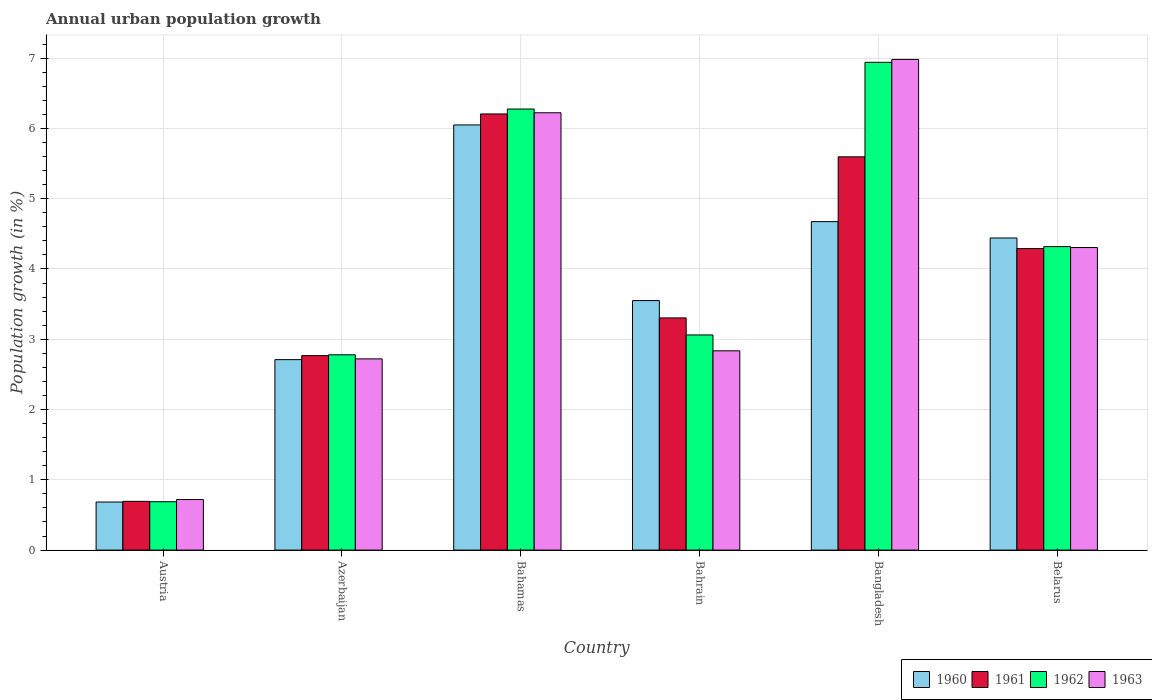How many groups of bars are there?
Your response must be concise. 6. Are the number of bars per tick equal to the number of legend labels?
Your response must be concise. Yes. Are the number of bars on each tick of the X-axis equal?
Your response must be concise. Yes. What is the percentage of urban population growth in 1962 in Austria?
Offer a very short reply. 0.69. Across all countries, what is the maximum percentage of urban population growth in 1961?
Keep it short and to the point. 6.21. Across all countries, what is the minimum percentage of urban population growth in 1962?
Ensure brevity in your answer.  0.69. In which country was the percentage of urban population growth in 1961 maximum?
Provide a succinct answer. Bahamas. In which country was the percentage of urban population growth in 1961 minimum?
Your answer should be very brief. Austria. What is the total percentage of urban population growth in 1961 in the graph?
Your response must be concise. 22.86. What is the difference between the percentage of urban population growth in 1963 in Azerbaijan and that in Bahrain?
Your answer should be compact. -0.11. What is the difference between the percentage of urban population growth in 1962 in Belarus and the percentage of urban population growth in 1960 in Bangladesh?
Give a very brief answer. -0.36. What is the average percentage of urban population growth in 1963 per country?
Your answer should be very brief. 3.96. What is the difference between the percentage of urban population growth of/in 1962 and percentage of urban population growth of/in 1961 in Bahamas?
Offer a very short reply. 0.07. In how many countries, is the percentage of urban population growth in 1960 greater than 4.6 %?
Offer a very short reply. 2. What is the ratio of the percentage of urban population growth in 1962 in Austria to that in Bahrain?
Your answer should be compact. 0.22. Is the difference between the percentage of urban population growth in 1962 in Austria and Bahrain greater than the difference between the percentage of urban population growth in 1961 in Austria and Bahrain?
Keep it short and to the point. Yes. What is the difference between the highest and the second highest percentage of urban population growth in 1961?
Offer a terse response. -1.31. What is the difference between the highest and the lowest percentage of urban population growth in 1960?
Offer a terse response. 5.37. In how many countries, is the percentage of urban population growth in 1961 greater than the average percentage of urban population growth in 1961 taken over all countries?
Offer a terse response. 3. What does the 1st bar from the left in Azerbaijan represents?
Give a very brief answer. 1960. What does the 4th bar from the right in Austria represents?
Ensure brevity in your answer.  1960. What is the difference between two consecutive major ticks on the Y-axis?
Keep it short and to the point. 1. Are the values on the major ticks of Y-axis written in scientific E-notation?
Your response must be concise. No. Does the graph contain any zero values?
Give a very brief answer. No. Does the graph contain grids?
Ensure brevity in your answer.  Yes. Where does the legend appear in the graph?
Make the answer very short. Bottom right. What is the title of the graph?
Give a very brief answer. Annual urban population growth. What is the label or title of the X-axis?
Offer a terse response. Country. What is the label or title of the Y-axis?
Your answer should be very brief. Population growth (in %). What is the Population growth (in %) of 1960 in Austria?
Your answer should be compact. 0.68. What is the Population growth (in %) of 1961 in Austria?
Ensure brevity in your answer.  0.69. What is the Population growth (in %) of 1962 in Austria?
Your response must be concise. 0.69. What is the Population growth (in %) of 1963 in Austria?
Ensure brevity in your answer.  0.72. What is the Population growth (in %) of 1960 in Azerbaijan?
Give a very brief answer. 2.71. What is the Population growth (in %) of 1961 in Azerbaijan?
Provide a succinct answer. 2.77. What is the Population growth (in %) in 1962 in Azerbaijan?
Offer a terse response. 2.78. What is the Population growth (in %) of 1963 in Azerbaijan?
Ensure brevity in your answer.  2.72. What is the Population growth (in %) in 1960 in Bahamas?
Your response must be concise. 6.05. What is the Population growth (in %) in 1961 in Bahamas?
Your response must be concise. 6.21. What is the Population growth (in %) in 1962 in Bahamas?
Your answer should be compact. 6.28. What is the Population growth (in %) in 1963 in Bahamas?
Give a very brief answer. 6.22. What is the Population growth (in %) of 1960 in Bahrain?
Keep it short and to the point. 3.55. What is the Population growth (in %) in 1961 in Bahrain?
Ensure brevity in your answer.  3.3. What is the Population growth (in %) of 1962 in Bahrain?
Your answer should be compact. 3.06. What is the Population growth (in %) in 1963 in Bahrain?
Provide a short and direct response. 2.84. What is the Population growth (in %) of 1960 in Bangladesh?
Ensure brevity in your answer.  4.67. What is the Population growth (in %) in 1961 in Bangladesh?
Give a very brief answer. 5.6. What is the Population growth (in %) of 1962 in Bangladesh?
Offer a very short reply. 6.94. What is the Population growth (in %) of 1963 in Bangladesh?
Give a very brief answer. 6.98. What is the Population growth (in %) of 1960 in Belarus?
Your response must be concise. 4.44. What is the Population growth (in %) of 1961 in Belarus?
Provide a succinct answer. 4.29. What is the Population growth (in %) of 1962 in Belarus?
Your response must be concise. 4.32. What is the Population growth (in %) of 1963 in Belarus?
Give a very brief answer. 4.31. Across all countries, what is the maximum Population growth (in %) of 1960?
Offer a terse response. 6.05. Across all countries, what is the maximum Population growth (in %) of 1961?
Your answer should be very brief. 6.21. Across all countries, what is the maximum Population growth (in %) in 1962?
Offer a very short reply. 6.94. Across all countries, what is the maximum Population growth (in %) of 1963?
Offer a terse response. 6.98. Across all countries, what is the minimum Population growth (in %) of 1960?
Make the answer very short. 0.68. Across all countries, what is the minimum Population growth (in %) in 1961?
Your answer should be very brief. 0.69. Across all countries, what is the minimum Population growth (in %) in 1962?
Keep it short and to the point. 0.69. Across all countries, what is the minimum Population growth (in %) of 1963?
Make the answer very short. 0.72. What is the total Population growth (in %) of 1960 in the graph?
Offer a terse response. 22.11. What is the total Population growth (in %) in 1961 in the graph?
Your response must be concise. 22.86. What is the total Population growth (in %) in 1962 in the graph?
Keep it short and to the point. 24.06. What is the total Population growth (in %) in 1963 in the graph?
Provide a short and direct response. 23.78. What is the difference between the Population growth (in %) of 1960 in Austria and that in Azerbaijan?
Keep it short and to the point. -2.03. What is the difference between the Population growth (in %) of 1961 in Austria and that in Azerbaijan?
Offer a very short reply. -2.07. What is the difference between the Population growth (in %) of 1962 in Austria and that in Azerbaijan?
Your answer should be very brief. -2.09. What is the difference between the Population growth (in %) in 1963 in Austria and that in Azerbaijan?
Your answer should be compact. -2. What is the difference between the Population growth (in %) of 1960 in Austria and that in Bahamas?
Your answer should be very brief. -5.37. What is the difference between the Population growth (in %) in 1961 in Austria and that in Bahamas?
Your response must be concise. -5.51. What is the difference between the Population growth (in %) of 1962 in Austria and that in Bahamas?
Offer a terse response. -5.59. What is the difference between the Population growth (in %) in 1963 in Austria and that in Bahamas?
Give a very brief answer. -5.5. What is the difference between the Population growth (in %) of 1960 in Austria and that in Bahrain?
Your answer should be very brief. -2.87. What is the difference between the Population growth (in %) of 1961 in Austria and that in Bahrain?
Your answer should be very brief. -2.61. What is the difference between the Population growth (in %) of 1962 in Austria and that in Bahrain?
Give a very brief answer. -2.37. What is the difference between the Population growth (in %) in 1963 in Austria and that in Bahrain?
Your response must be concise. -2.12. What is the difference between the Population growth (in %) in 1960 in Austria and that in Bangladesh?
Keep it short and to the point. -3.99. What is the difference between the Population growth (in %) in 1961 in Austria and that in Bangladesh?
Make the answer very short. -4.9. What is the difference between the Population growth (in %) in 1962 in Austria and that in Bangladesh?
Give a very brief answer. -6.25. What is the difference between the Population growth (in %) in 1963 in Austria and that in Bangladesh?
Make the answer very short. -6.26. What is the difference between the Population growth (in %) in 1960 in Austria and that in Belarus?
Provide a succinct answer. -3.76. What is the difference between the Population growth (in %) of 1961 in Austria and that in Belarus?
Ensure brevity in your answer.  -3.6. What is the difference between the Population growth (in %) of 1962 in Austria and that in Belarus?
Give a very brief answer. -3.63. What is the difference between the Population growth (in %) in 1963 in Austria and that in Belarus?
Offer a very short reply. -3.59. What is the difference between the Population growth (in %) in 1960 in Azerbaijan and that in Bahamas?
Your response must be concise. -3.34. What is the difference between the Population growth (in %) in 1961 in Azerbaijan and that in Bahamas?
Your answer should be very brief. -3.44. What is the difference between the Population growth (in %) of 1962 in Azerbaijan and that in Bahamas?
Make the answer very short. -3.5. What is the difference between the Population growth (in %) of 1963 in Azerbaijan and that in Bahamas?
Offer a terse response. -3.5. What is the difference between the Population growth (in %) of 1960 in Azerbaijan and that in Bahrain?
Offer a very short reply. -0.84. What is the difference between the Population growth (in %) in 1961 in Azerbaijan and that in Bahrain?
Keep it short and to the point. -0.54. What is the difference between the Population growth (in %) in 1962 in Azerbaijan and that in Bahrain?
Give a very brief answer. -0.28. What is the difference between the Population growth (in %) in 1963 in Azerbaijan and that in Bahrain?
Give a very brief answer. -0.11. What is the difference between the Population growth (in %) of 1960 in Azerbaijan and that in Bangladesh?
Your response must be concise. -1.96. What is the difference between the Population growth (in %) in 1961 in Azerbaijan and that in Bangladesh?
Provide a short and direct response. -2.83. What is the difference between the Population growth (in %) of 1962 in Azerbaijan and that in Bangladesh?
Your answer should be very brief. -4.16. What is the difference between the Population growth (in %) in 1963 in Azerbaijan and that in Bangladesh?
Keep it short and to the point. -4.26. What is the difference between the Population growth (in %) in 1960 in Azerbaijan and that in Belarus?
Your response must be concise. -1.73. What is the difference between the Population growth (in %) in 1961 in Azerbaijan and that in Belarus?
Offer a terse response. -1.52. What is the difference between the Population growth (in %) in 1962 in Azerbaijan and that in Belarus?
Provide a short and direct response. -1.54. What is the difference between the Population growth (in %) in 1963 in Azerbaijan and that in Belarus?
Offer a terse response. -1.58. What is the difference between the Population growth (in %) of 1960 in Bahamas and that in Bahrain?
Keep it short and to the point. 2.5. What is the difference between the Population growth (in %) of 1961 in Bahamas and that in Bahrain?
Provide a short and direct response. 2.9. What is the difference between the Population growth (in %) of 1962 in Bahamas and that in Bahrain?
Keep it short and to the point. 3.21. What is the difference between the Population growth (in %) in 1963 in Bahamas and that in Bahrain?
Your answer should be very brief. 3.39. What is the difference between the Population growth (in %) in 1960 in Bahamas and that in Bangladesh?
Your answer should be compact. 1.38. What is the difference between the Population growth (in %) in 1961 in Bahamas and that in Bangladesh?
Make the answer very short. 0.61. What is the difference between the Population growth (in %) of 1962 in Bahamas and that in Bangladesh?
Make the answer very short. -0.66. What is the difference between the Population growth (in %) of 1963 in Bahamas and that in Bangladesh?
Give a very brief answer. -0.76. What is the difference between the Population growth (in %) in 1960 in Bahamas and that in Belarus?
Give a very brief answer. 1.61. What is the difference between the Population growth (in %) in 1961 in Bahamas and that in Belarus?
Make the answer very short. 1.92. What is the difference between the Population growth (in %) of 1962 in Bahamas and that in Belarus?
Offer a very short reply. 1.96. What is the difference between the Population growth (in %) of 1963 in Bahamas and that in Belarus?
Provide a succinct answer. 1.92. What is the difference between the Population growth (in %) of 1960 in Bahrain and that in Bangladesh?
Offer a terse response. -1.12. What is the difference between the Population growth (in %) in 1961 in Bahrain and that in Bangladesh?
Ensure brevity in your answer.  -2.29. What is the difference between the Population growth (in %) in 1962 in Bahrain and that in Bangladesh?
Offer a terse response. -3.88. What is the difference between the Population growth (in %) in 1963 in Bahrain and that in Bangladesh?
Your answer should be very brief. -4.15. What is the difference between the Population growth (in %) of 1960 in Bahrain and that in Belarus?
Provide a succinct answer. -0.89. What is the difference between the Population growth (in %) in 1961 in Bahrain and that in Belarus?
Offer a terse response. -0.99. What is the difference between the Population growth (in %) in 1962 in Bahrain and that in Belarus?
Provide a succinct answer. -1.26. What is the difference between the Population growth (in %) of 1963 in Bahrain and that in Belarus?
Your answer should be very brief. -1.47. What is the difference between the Population growth (in %) of 1960 in Bangladesh and that in Belarus?
Offer a very short reply. 0.23. What is the difference between the Population growth (in %) of 1961 in Bangladesh and that in Belarus?
Your answer should be very brief. 1.31. What is the difference between the Population growth (in %) of 1962 in Bangladesh and that in Belarus?
Keep it short and to the point. 2.62. What is the difference between the Population growth (in %) in 1963 in Bangladesh and that in Belarus?
Your answer should be very brief. 2.68. What is the difference between the Population growth (in %) of 1960 in Austria and the Population growth (in %) of 1961 in Azerbaijan?
Make the answer very short. -2.08. What is the difference between the Population growth (in %) of 1960 in Austria and the Population growth (in %) of 1962 in Azerbaijan?
Ensure brevity in your answer.  -2.09. What is the difference between the Population growth (in %) in 1960 in Austria and the Population growth (in %) in 1963 in Azerbaijan?
Give a very brief answer. -2.04. What is the difference between the Population growth (in %) in 1961 in Austria and the Population growth (in %) in 1962 in Azerbaijan?
Ensure brevity in your answer.  -2.08. What is the difference between the Population growth (in %) in 1961 in Austria and the Population growth (in %) in 1963 in Azerbaijan?
Your answer should be very brief. -2.03. What is the difference between the Population growth (in %) in 1962 in Austria and the Population growth (in %) in 1963 in Azerbaijan?
Make the answer very short. -2.03. What is the difference between the Population growth (in %) in 1960 in Austria and the Population growth (in %) in 1961 in Bahamas?
Provide a succinct answer. -5.52. What is the difference between the Population growth (in %) of 1960 in Austria and the Population growth (in %) of 1962 in Bahamas?
Provide a short and direct response. -5.59. What is the difference between the Population growth (in %) in 1960 in Austria and the Population growth (in %) in 1963 in Bahamas?
Offer a very short reply. -5.54. What is the difference between the Population growth (in %) in 1961 in Austria and the Population growth (in %) in 1962 in Bahamas?
Your response must be concise. -5.58. What is the difference between the Population growth (in %) of 1961 in Austria and the Population growth (in %) of 1963 in Bahamas?
Your response must be concise. -5.53. What is the difference between the Population growth (in %) in 1962 in Austria and the Population growth (in %) in 1963 in Bahamas?
Give a very brief answer. -5.53. What is the difference between the Population growth (in %) of 1960 in Austria and the Population growth (in %) of 1961 in Bahrain?
Your response must be concise. -2.62. What is the difference between the Population growth (in %) of 1960 in Austria and the Population growth (in %) of 1962 in Bahrain?
Keep it short and to the point. -2.38. What is the difference between the Population growth (in %) of 1960 in Austria and the Population growth (in %) of 1963 in Bahrain?
Keep it short and to the point. -2.15. What is the difference between the Population growth (in %) of 1961 in Austria and the Population growth (in %) of 1962 in Bahrain?
Ensure brevity in your answer.  -2.37. What is the difference between the Population growth (in %) in 1961 in Austria and the Population growth (in %) in 1963 in Bahrain?
Provide a succinct answer. -2.14. What is the difference between the Population growth (in %) in 1962 in Austria and the Population growth (in %) in 1963 in Bahrain?
Your response must be concise. -2.15. What is the difference between the Population growth (in %) in 1960 in Austria and the Population growth (in %) in 1961 in Bangladesh?
Your answer should be compact. -4.91. What is the difference between the Population growth (in %) in 1960 in Austria and the Population growth (in %) in 1962 in Bangladesh?
Your response must be concise. -6.26. What is the difference between the Population growth (in %) in 1960 in Austria and the Population growth (in %) in 1963 in Bangladesh?
Keep it short and to the point. -6.3. What is the difference between the Population growth (in %) of 1961 in Austria and the Population growth (in %) of 1962 in Bangladesh?
Your answer should be very brief. -6.25. What is the difference between the Population growth (in %) in 1961 in Austria and the Population growth (in %) in 1963 in Bangladesh?
Your answer should be compact. -6.29. What is the difference between the Population growth (in %) in 1962 in Austria and the Population growth (in %) in 1963 in Bangladesh?
Your answer should be very brief. -6.29. What is the difference between the Population growth (in %) of 1960 in Austria and the Population growth (in %) of 1961 in Belarus?
Provide a short and direct response. -3.61. What is the difference between the Population growth (in %) of 1960 in Austria and the Population growth (in %) of 1962 in Belarus?
Ensure brevity in your answer.  -3.63. What is the difference between the Population growth (in %) of 1960 in Austria and the Population growth (in %) of 1963 in Belarus?
Your answer should be very brief. -3.62. What is the difference between the Population growth (in %) in 1961 in Austria and the Population growth (in %) in 1962 in Belarus?
Your response must be concise. -3.62. What is the difference between the Population growth (in %) of 1961 in Austria and the Population growth (in %) of 1963 in Belarus?
Make the answer very short. -3.61. What is the difference between the Population growth (in %) of 1962 in Austria and the Population growth (in %) of 1963 in Belarus?
Provide a short and direct response. -3.62. What is the difference between the Population growth (in %) of 1960 in Azerbaijan and the Population growth (in %) of 1961 in Bahamas?
Your answer should be compact. -3.5. What is the difference between the Population growth (in %) in 1960 in Azerbaijan and the Population growth (in %) in 1962 in Bahamas?
Provide a succinct answer. -3.57. What is the difference between the Population growth (in %) in 1960 in Azerbaijan and the Population growth (in %) in 1963 in Bahamas?
Provide a short and direct response. -3.51. What is the difference between the Population growth (in %) in 1961 in Azerbaijan and the Population growth (in %) in 1962 in Bahamas?
Ensure brevity in your answer.  -3.51. What is the difference between the Population growth (in %) in 1961 in Azerbaijan and the Population growth (in %) in 1963 in Bahamas?
Make the answer very short. -3.46. What is the difference between the Population growth (in %) of 1962 in Azerbaijan and the Population growth (in %) of 1963 in Bahamas?
Make the answer very short. -3.44. What is the difference between the Population growth (in %) in 1960 in Azerbaijan and the Population growth (in %) in 1961 in Bahrain?
Your answer should be compact. -0.59. What is the difference between the Population growth (in %) in 1960 in Azerbaijan and the Population growth (in %) in 1962 in Bahrain?
Make the answer very short. -0.35. What is the difference between the Population growth (in %) of 1960 in Azerbaijan and the Population growth (in %) of 1963 in Bahrain?
Your answer should be compact. -0.13. What is the difference between the Population growth (in %) of 1961 in Azerbaijan and the Population growth (in %) of 1962 in Bahrain?
Provide a short and direct response. -0.29. What is the difference between the Population growth (in %) of 1961 in Azerbaijan and the Population growth (in %) of 1963 in Bahrain?
Offer a terse response. -0.07. What is the difference between the Population growth (in %) of 1962 in Azerbaijan and the Population growth (in %) of 1963 in Bahrain?
Offer a very short reply. -0.06. What is the difference between the Population growth (in %) in 1960 in Azerbaijan and the Population growth (in %) in 1961 in Bangladesh?
Your answer should be compact. -2.89. What is the difference between the Population growth (in %) of 1960 in Azerbaijan and the Population growth (in %) of 1962 in Bangladesh?
Provide a short and direct response. -4.23. What is the difference between the Population growth (in %) in 1960 in Azerbaijan and the Population growth (in %) in 1963 in Bangladesh?
Ensure brevity in your answer.  -4.27. What is the difference between the Population growth (in %) of 1961 in Azerbaijan and the Population growth (in %) of 1962 in Bangladesh?
Keep it short and to the point. -4.17. What is the difference between the Population growth (in %) in 1961 in Azerbaijan and the Population growth (in %) in 1963 in Bangladesh?
Ensure brevity in your answer.  -4.21. What is the difference between the Population growth (in %) in 1962 in Azerbaijan and the Population growth (in %) in 1963 in Bangladesh?
Make the answer very short. -4.2. What is the difference between the Population growth (in %) of 1960 in Azerbaijan and the Population growth (in %) of 1961 in Belarus?
Ensure brevity in your answer.  -1.58. What is the difference between the Population growth (in %) of 1960 in Azerbaijan and the Population growth (in %) of 1962 in Belarus?
Give a very brief answer. -1.61. What is the difference between the Population growth (in %) of 1960 in Azerbaijan and the Population growth (in %) of 1963 in Belarus?
Your answer should be compact. -1.6. What is the difference between the Population growth (in %) of 1961 in Azerbaijan and the Population growth (in %) of 1962 in Belarus?
Make the answer very short. -1.55. What is the difference between the Population growth (in %) in 1961 in Azerbaijan and the Population growth (in %) in 1963 in Belarus?
Give a very brief answer. -1.54. What is the difference between the Population growth (in %) in 1962 in Azerbaijan and the Population growth (in %) in 1963 in Belarus?
Your answer should be very brief. -1.53. What is the difference between the Population growth (in %) of 1960 in Bahamas and the Population growth (in %) of 1961 in Bahrain?
Give a very brief answer. 2.75. What is the difference between the Population growth (in %) of 1960 in Bahamas and the Population growth (in %) of 1962 in Bahrain?
Make the answer very short. 2.99. What is the difference between the Population growth (in %) in 1960 in Bahamas and the Population growth (in %) in 1963 in Bahrain?
Your answer should be compact. 3.21. What is the difference between the Population growth (in %) in 1961 in Bahamas and the Population growth (in %) in 1962 in Bahrain?
Ensure brevity in your answer.  3.14. What is the difference between the Population growth (in %) in 1961 in Bahamas and the Population growth (in %) in 1963 in Bahrain?
Provide a short and direct response. 3.37. What is the difference between the Population growth (in %) of 1962 in Bahamas and the Population growth (in %) of 1963 in Bahrain?
Ensure brevity in your answer.  3.44. What is the difference between the Population growth (in %) of 1960 in Bahamas and the Population growth (in %) of 1961 in Bangladesh?
Offer a very short reply. 0.45. What is the difference between the Population growth (in %) in 1960 in Bahamas and the Population growth (in %) in 1962 in Bangladesh?
Your answer should be compact. -0.89. What is the difference between the Population growth (in %) of 1960 in Bahamas and the Population growth (in %) of 1963 in Bangladesh?
Provide a succinct answer. -0.93. What is the difference between the Population growth (in %) in 1961 in Bahamas and the Population growth (in %) in 1962 in Bangladesh?
Make the answer very short. -0.73. What is the difference between the Population growth (in %) of 1961 in Bahamas and the Population growth (in %) of 1963 in Bangladesh?
Your answer should be compact. -0.78. What is the difference between the Population growth (in %) of 1962 in Bahamas and the Population growth (in %) of 1963 in Bangladesh?
Your answer should be very brief. -0.71. What is the difference between the Population growth (in %) of 1960 in Bahamas and the Population growth (in %) of 1961 in Belarus?
Provide a succinct answer. 1.76. What is the difference between the Population growth (in %) of 1960 in Bahamas and the Population growth (in %) of 1962 in Belarus?
Offer a terse response. 1.73. What is the difference between the Population growth (in %) in 1960 in Bahamas and the Population growth (in %) in 1963 in Belarus?
Your response must be concise. 1.74. What is the difference between the Population growth (in %) of 1961 in Bahamas and the Population growth (in %) of 1962 in Belarus?
Provide a succinct answer. 1.89. What is the difference between the Population growth (in %) of 1961 in Bahamas and the Population growth (in %) of 1963 in Belarus?
Your answer should be compact. 1.9. What is the difference between the Population growth (in %) in 1962 in Bahamas and the Population growth (in %) in 1963 in Belarus?
Your answer should be very brief. 1.97. What is the difference between the Population growth (in %) of 1960 in Bahrain and the Population growth (in %) of 1961 in Bangladesh?
Offer a terse response. -2.05. What is the difference between the Population growth (in %) in 1960 in Bahrain and the Population growth (in %) in 1962 in Bangladesh?
Offer a very short reply. -3.39. What is the difference between the Population growth (in %) of 1960 in Bahrain and the Population growth (in %) of 1963 in Bangladesh?
Keep it short and to the point. -3.43. What is the difference between the Population growth (in %) of 1961 in Bahrain and the Population growth (in %) of 1962 in Bangladesh?
Offer a terse response. -3.64. What is the difference between the Population growth (in %) in 1961 in Bahrain and the Population growth (in %) in 1963 in Bangladesh?
Your response must be concise. -3.68. What is the difference between the Population growth (in %) of 1962 in Bahrain and the Population growth (in %) of 1963 in Bangladesh?
Provide a short and direct response. -3.92. What is the difference between the Population growth (in %) in 1960 in Bahrain and the Population growth (in %) in 1961 in Belarus?
Your answer should be compact. -0.74. What is the difference between the Population growth (in %) in 1960 in Bahrain and the Population growth (in %) in 1962 in Belarus?
Provide a short and direct response. -0.77. What is the difference between the Population growth (in %) of 1960 in Bahrain and the Population growth (in %) of 1963 in Belarus?
Make the answer very short. -0.75. What is the difference between the Population growth (in %) in 1961 in Bahrain and the Population growth (in %) in 1962 in Belarus?
Provide a short and direct response. -1.01. What is the difference between the Population growth (in %) in 1961 in Bahrain and the Population growth (in %) in 1963 in Belarus?
Make the answer very short. -1. What is the difference between the Population growth (in %) of 1962 in Bahrain and the Population growth (in %) of 1963 in Belarus?
Provide a short and direct response. -1.24. What is the difference between the Population growth (in %) in 1960 in Bangladesh and the Population growth (in %) in 1961 in Belarus?
Keep it short and to the point. 0.38. What is the difference between the Population growth (in %) of 1960 in Bangladesh and the Population growth (in %) of 1962 in Belarus?
Your answer should be very brief. 0.36. What is the difference between the Population growth (in %) of 1960 in Bangladesh and the Population growth (in %) of 1963 in Belarus?
Offer a very short reply. 0.37. What is the difference between the Population growth (in %) of 1961 in Bangladesh and the Population growth (in %) of 1962 in Belarus?
Keep it short and to the point. 1.28. What is the difference between the Population growth (in %) in 1961 in Bangladesh and the Population growth (in %) in 1963 in Belarus?
Your answer should be very brief. 1.29. What is the difference between the Population growth (in %) of 1962 in Bangladesh and the Population growth (in %) of 1963 in Belarus?
Keep it short and to the point. 2.63. What is the average Population growth (in %) in 1960 per country?
Provide a succinct answer. 3.68. What is the average Population growth (in %) in 1961 per country?
Give a very brief answer. 3.81. What is the average Population growth (in %) of 1962 per country?
Ensure brevity in your answer.  4.01. What is the average Population growth (in %) in 1963 per country?
Ensure brevity in your answer.  3.96. What is the difference between the Population growth (in %) in 1960 and Population growth (in %) in 1961 in Austria?
Offer a very short reply. -0.01. What is the difference between the Population growth (in %) in 1960 and Population growth (in %) in 1962 in Austria?
Your answer should be compact. -0. What is the difference between the Population growth (in %) of 1960 and Population growth (in %) of 1963 in Austria?
Your response must be concise. -0.04. What is the difference between the Population growth (in %) in 1961 and Population growth (in %) in 1962 in Austria?
Give a very brief answer. 0.01. What is the difference between the Population growth (in %) of 1961 and Population growth (in %) of 1963 in Austria?
Provide a succinct answer. -0.03. What is the difference between the Population growth (in %) in 1962 and Population growth (in %) in 1963 in Austria?
Give a very brief answer. -0.03. What is the difference between the Population growth (in %) of 1960 and Population growth (in %) of 1961 in Azerbaijan?
Make the answer very short. -0.06. What is the difference between the Population growth (in %) of 1960 and Population growth (in %) of 1962 in Azerbaijan?
Provide a succinct answer. -0.07. What is the difference between the Population growth (in %) in 1960 and Population growth (in %) in 1963 in Azerbaijan?
Make the answer very short. -0.01. What is the difference between the Population growth (in %) of 1961 and Population growth (in %) of 1962 in Azerbaijan?
Ensure brevity in your answer.  -0.01. What is the difference between the Population growth (in %) in 1961 and Population growth (in %) in 1963 in Azerbaijan?
Keep it short and to the point. 0.05. What is the difference between the Population growth (in %) in 1962 and Population growth (in %) in 1963 in Azerbaijan?
Ensure brevity in your answer.  0.06. What is the difference between the Population growth (in %) of 1960 and Population growth (in %) of 1961 in Bahamas?
Keep it short and to the point. -0.16. What is the difference between the Population growth (in %) of 1960 and Population growth (in %) of 1962 in Bahamas?
Ensure brevity in your answer.  -0.23. What is the difference between the Population growth (in %) in 1960 and Population growth (in %) in 1963 in Bahamas?
Provide a succinct answer. -0.17. What is the difference between the Population growth (in %) of 1961 and Population growth (in %) of 1962 in Bahamas?
Provide a succinct answer. -0.07. What is the difference between the Population growth (in %) in 1961 and Population growth (in %) in 1963 in Bahamas?
Your response must be concise. -0.02. What is the difference between the Population growth (in %) of 1962 and Population growth (in %) of 1963 in Bahamas?
Offer a very short reply. 0.05. What is the difference between the Population growth (in %) in 1960 and Population growth (in %) in 1961 in Bahrain?
Keep it short and to the point. 0.25. What is the difference between the Population growth (in %) of 1960 and Population growth (in %) of 1962 in Bahrain?
Your answer should be very brief. 0.49. What is the difference between the Population growth (in %) in 1960 and Population growth (in %) in 1963 in Bahrain?
Provide a short and direct response. 0.71. What is the difference between the Population growth (in %) of 1961 and Population growth (in %) of 1962 in Bahrain?
Give a very brief answer. 0.24. What is the difference between the Population growth (in %) in 1961 and Population growth (in %) in 1963 in Bahrain?
Make the answer very short. 0.47. What is the difference between the Population growth (in %) of 1962 and Population growth (in %) of 1963 in Bahrain?
Give a very brief answer. 0.23. What is the difference between the Population growth (in %) in 1960 and Population growth (in %) in 1961 in Bangladesh?
Your response must be concise. -0.92. What is the difference between the Population growth (in %) of 1960 and Population growth (in %) of 1962 in Bangladesh?
Provide a short and direct response. -2.27. What is the difference between the Population growth (in %) in 1960 and Population growth (in %) in 1963 in Bangladesh?
Your response must be concise. -2.31. What is the difference between the Population growth (in %) of 1961 and Population growth (in %) of 1962 in Bangladesh?
Provide a succinct answer. -1.34. What is the difference between the Population growth (in %) in 1961 and Population growth (in %) in 1963 in Bangladesh?
Give a very brief answer. -1.39. What is the difference between the Population growth (in %) in 1962 and Population growth (in %) in 1963 in Bangladesh?
Your answer should be compact. -0.04. What is the difference between the Population growth (in %) of 1960 and Population growth (in %) of 1961 in Belarus?
Ensure brevity in your answer.  0.15. What is the difference between the Population growth (in %) in 1960 and Population growth (in %) in 1962 in Belarus?
Ensure brevity in your answer.  0.12. What is the difference between the Population growth (in %) in 1960 and Population growth (in %) in 1963 in Belarus?
Keep it short and to the point. 0.14. What is the difference between the Population growth (in %) of 1961 and Population growth (in %) of 1962 in Belarus?
Your response must be concise. -0.03. What is the difference between the Population growth (in %) of 1961 and Population growth (in %) of 1963 in Belarus?
Offer a very short reply. -0.01. What is the difference between the Population growth (in %) in 1962 and Population growth (in %) in 1963 in Belarus?
Ensure brevity in your answer.  0.01. What is the ratio of the Population growth (in %) in 1960 in Austria to that in Azerbaijan?
Offer a very short reply. 0.25. What is the ratio of the Population growth (in %) of 1961 in Austria to that in Azerbaijan?
Your answer should be very brief. 0.25. What is the ratio of the Population growth (in %) of 1962 in Austria to that in Azerbaijan?
Your response must be concise. 0.25. What is the ratio of the Population growth (in %) of 1963 in Austria to that in Azerbaijan?
Your response must be concise. 0.26. What is the ratio of the Population growth (in %) in 1960 in Austria to that in Bahamas?
Offer a very short reply. 0.11. What is the ratio of the Population growth (in %) in 1961 in Austria to that in Bahamas?
Offer a very short reply. 0.11. What is the ratio of the Population growth (in %) in 1962 in Austria to that in Bahamas?
Make the answer very short. 0.11. What is the ratio of the Population growth (in %) of 1963 in Austria to that in Bahamas?
Make the answer very short. 0.12. What is the ratio of the Population growth (in %) of 1960 in Austria to that in Bahrain?
Give a very brief answer. 0.19. What is the ratio of the Population growth (in %) in 1961 in Austria to that in Bahrain?
Offer a terse response. 0.21. What is the ratio of the Population growth (in %) in 1962 in Austria to that in Bahrain?
Your answer should be compact. 0.22. What is the ratio of the Population growth (in %) in 1963 in Austria to that in Bahrain?
Your response must be concise. 0.25. What is the ratio of the Population growth (in %) of 1960 in Austria to that in Bangladesh?
Provide a succinct answer. 0.15. What is the ratio of the Population growth (in %) in 1961 in Austria to that in Bangladesh?
Make the answer very short. 0.12. What is the ratio of the Population growth (in %) in 1962 in Austria to that in Bangladesh?
Offer a terse response. 0.1. What is the ratio of the Population growth (in %) in 1963 in Austria to that in Bangladesh?
Offer a very short reply. 0.1. What is the ratio of the Population growth (in %) in 1960 in Austria to that in Belarus?
Provide a succinct answer. 0.15. What is the ratio of the Population growth (in %) in 1961 in Austria to that in Belarus?
Provide a succinct answer. 0.16. What is the ratio of the Population growth (in %) of 1962 in Austria to that in Belarus?
Offer a very short reply. 0.16. What is the ratio of the Population growth (in %) in 1963 in Austria to that in Belarus?
Give a very brief answer. 0.17. What is the ratio of the Population growth (in %) of 1960 in Azerbaijan to that in Bahamas?
Keep it short and to the point. 0.45. What is the ratio of the Population growth (in %) of 1961 in Azerbaijan to that in Bahamas?
Your response must be concise. 0.45. What is the ratio of the Population growth (in %) in 1962 in Azerbaijan to that in Bahamas?
Your answer should be very brief. 0.44. What is the ratio of the Population growth (in %) in 1963 in Azerbaijan to that in Bahamas?
Your answer should be very brief. 0.44. What is the ratio of the Population growth (in %) in 1960 in Azerbaijan to that in Bahrain?
Provide a succinct answer. 0.76. What is the ratio of the Population growth (in %) in 1961 in Azerbaijan to that in Bahrain?
Ensure brevity in your answer.  0.84. What is the ratio of the Population growth (in %) in 1962 in Azerbaijan to that in Bahrain?
Give a very brief answer. 0.91. What is the ratio of the Population growth (in %) of 1963 in Azerbaijan to that in Bahrain?
Offer a terse response. 0.96. What is the ratio of the Population growth (in %) in 1960 in Azerbaijan to that in Bangladesh?
Ensure brevity in your answer.  0.58. What is the ratio of the Population growth (in %) of 1961 in Azerbaijan to that in Bangladesh?
Offer a very short reply. 0.49. What is the ratio of the Population growth (in %) in 1962 in Azerbaijan to that in Bangladesh?
Provide a short and direct response. 0.4. What is the ratio of the Population growth (in %) in 1963 in Azerbaijan to that in Bangladesh?
Your response must be concise. 0.39. What is the ratio of the Population growth (in %) in 1960 in Azerbaijan to that in Belarus?
Provide a short and direct response. 0.61. What is the ratio of the Population growth (in %) of 1961 in Azerbaijan to that in Belarus?
Offer a very short reply. 0.64. What is the ratio of the Population growth (in %) of 1962 in Azerbaijan to that in Belarus?
Offer a terse response. 0.64. What is the ratio of the Population growth (in %) in 1963 in Azerbaijan to that in Belarus?
Give a very brief answer. 0.63. What is the ratio of the Population growth (in %) of 1960 in Bahamas to that in Bahrain?
Provide a short and direct response. 1.7. What is the ratio of the Population growth (in %) of 1961 in Bahamas to that in Bahrain?
Provide a short and direct response. 1.88. What is the ratio of the Population growth (in %) in 1962 in Bahamas to that in Bahrain?
Ensure brevity in your answer.  2.05. What is the ratio of the Population growth (in %) of 1963 in Bahamas to that in Bahrain?
Keep it short and to the point. 2.19. What is the ratio of the Population growth (in %) in 1960 in Bahamas to that in Bangladesh?
Keep it short and to the point. 1.29. What is the ratio of the Population growth (in %) in 1961 in Bahamas to that in Bangladesh?
Keep it short and to the point. 1.11. What is the ratio of the Population growth (in %) in 1962 in Bahamas to that in Bangladesh?
Make the answer very short. 0.9. What is the ratio of the Population growth (in %) of 1963 in Bahamas to that in Bangladesh?
Keep it short and to the point. 0.89. What is the ratio of the Population growth (in %) in 1960 in Bahamas to that in Belarus?
Provide a succinct answer. 1.36. What is the ratio of the Population growth (in %) in 1961 in Bahamas to that in Belarus?
Make the answer very short. 1.45. What is the ratio of the Population growth (in %) in 1962 in Bahamas to that in Belarus?
Ensure brevity in your answer.  1.45. What is the ratio of the Population growth (in %) of 1963 in Bahamas to that in Belarus?
Provide a succinct answer. 1.45. What is the ratio of the Population growth (in %) of 1960 in Bahrain to that in Bangladesh?
Provide a short and direct response. 0.76. What is the ratio of the Population growth (in %) of 1961 in Bahrain to that in Bangladesh?
Your answer should be very brief. 0.59. What is the ratio of the Population growth (in %) in 1962 in Bahrain to that in Bangladesh?
Keep it short and to the point. 0.44. What is the ratio of the Population growth (in %) in 1963 in Bahrain to that in Bangladesh?
Your answer should be compact. 0.41. What is the ratio of the Population growth (in %) in 1960 in Bahrain to that in Belarus?
Your answer should be compact. 0.8. What is the ratio of the Population growth (in %) of 1961 in Bahrain to that in Belarus?
Give a very brief answer. 0.77. What is the ratio of the Population growth (in %) in 1962 in Bahrain to that in Belarus?
Provide a short and direct response. 0.71. What is the ratio of the Population growth (in %) of 1963 in Bahrain to that in Belarus?
Your response must be concise. 0.66. What is the ratio of the Population growth (in %) of 1960 in Bangladesh to that in Belarus?
Your answer should be very brief. 1.05. What is the ratio of the Population growth (in %) of 1961 in Bangladesh to that in Belarus?
Offer a terse response. 1.3. What is the ratio of the Population growth (in %) in 1962 in Bangladesh to that in Belarus?
Ensure brevity in your answer.  1.61. What is the ratio of the Population growth (in %) of 1963 in Bangladesh to that in Belarus?
Provide a succinct answer. 1.62. What is the difference between the highest and the second highest Population growth (in %) of 1960?
Provide a short and direct response. 1.38. What is the difference between the highest and the second highest Population growth (in %) of 1961?
Give a very brief answer. 0.61. What is the difference between the highest and the second highest Population growth (in %) of 1962?
Your answer should be compact. 0.66. What is the difference between the highest and the second highest Population growth (in %) of 1963?
Provide a short and direct response. 0.76. What is the difference between the highest and the lowest Population growth (in %) in 1960?
Your answer should be very brief. 5.37. What is the difference between the highest and the lowest Population growth (in %) in 1961?
Your answer should be very brief. 5.51. What is the difference between the highest and the lowest Population growth (in %) of 1962?
Your response must be concise. 6.25. What is the difference between the highest and the lowest Population growth (in %) in 1963?
Give a very brief answer. 6.26. 